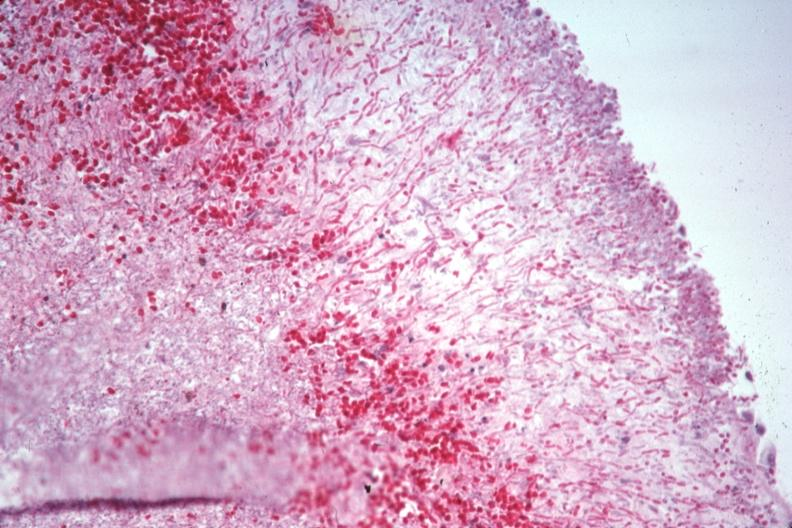does this image show pas large number pseudohyphae penetrating capsule which can not be recognized as spleen?
Answer the question using a single word or phrase. Yes 